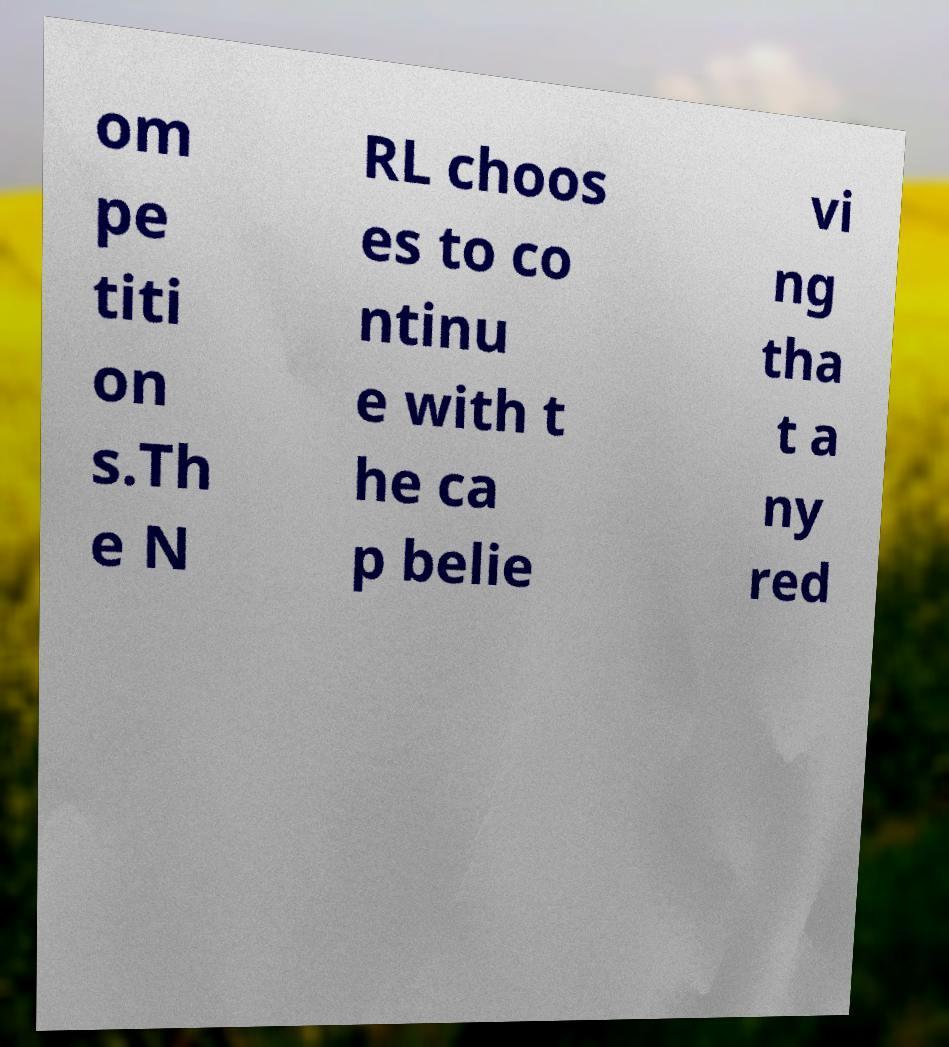I need the written content from this picture converted into text. Can you do that? om pe titi on s.Th e N RL choos es to co ntinu e with t he ca p belie vi ng tha t a ny red 